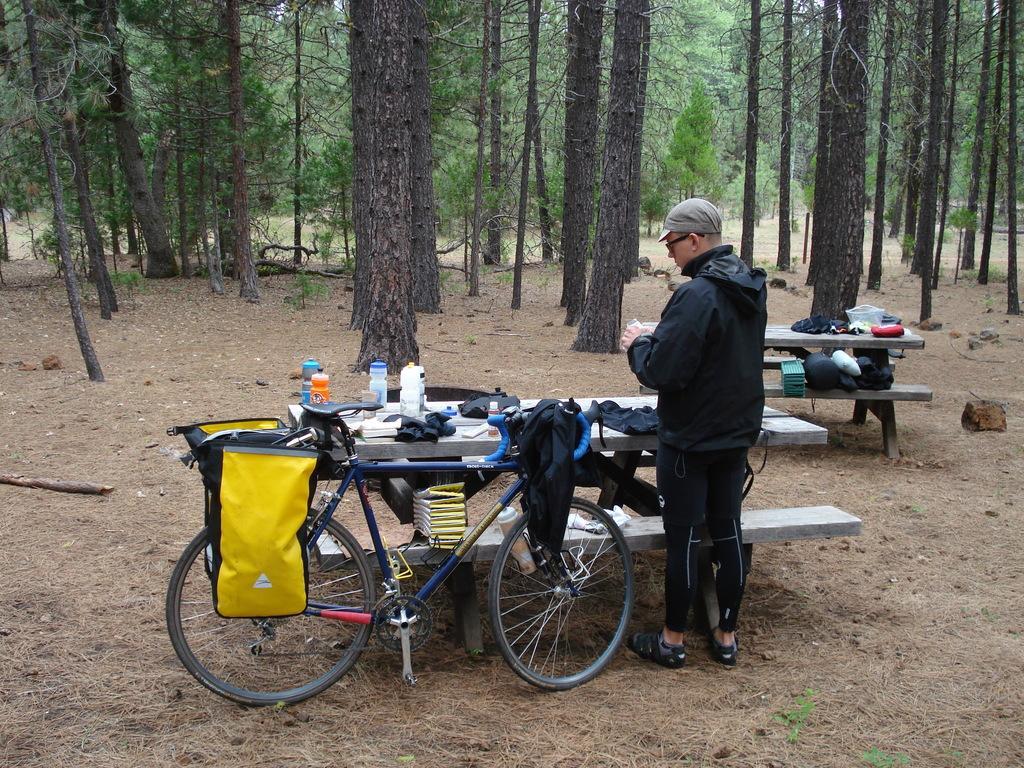In one or two sentences, can you explain what this image depicts? This person standing and wear cap and glasses. We can see benches and tables,on the table we can see clothes,covers,bottles,on the benches we can see books,bags. We can see bag and cloth on the bicycle. There are trees. 